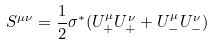<formula> <loc_0><loc_0><loc_500><loc_500>S ^ { \mu \nu } = \frac { 1 } { 2 } \sigma ^ { * } ( U _ { + } ^ { \mu } U _ { + } ^ { \nu } + U _ { - } ^ { \mu } U _ { - } ^ { \nu } )</formula> 